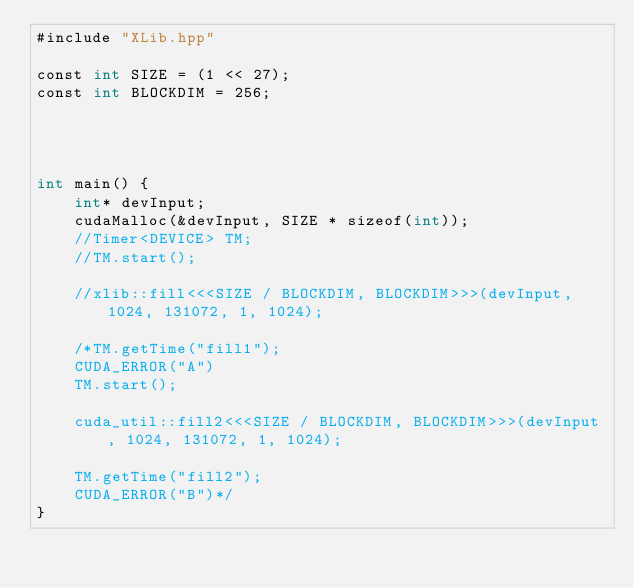<code> <loc_0><loc_0><loc_500><loc_500><_Cuda_>#include "XLib.hpp"

const int SIZE = (1 << 27);
const int BLOCKDIM = 256;




int main() {
    int* devInput;
    cudaMalloc(&devInput, SIZE * sizeof(int));
    //Timer<DEVICE> TM;
    //TM.start();

    //xlib::fill<<<SIZE / BLOCKDIM, BLOCKDIM>>>(devInput, 1024, 131072, 1, 1024);

    /*TM.getTime("fill1");
    CUDA_ERROR("A")
    TM.start();

    cuda_util::fill2<<<SIZE / BLOCKDIM, BLOCKDIM>>>(devInput, 1024, 131072, 1, 1024);

    TM.getTime("fill2");
    CUDA_ERROR("B")*/
}
</code> 